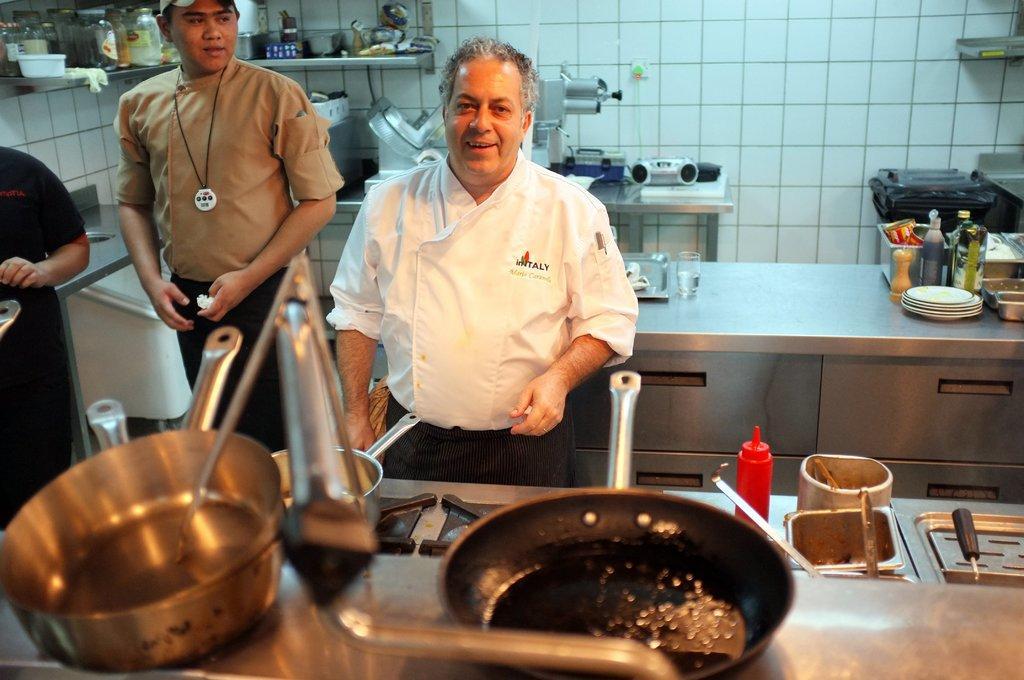Describe this image in one or two sentences. In this picture we can see three people where two men are standing and smiling, pan, bowls, bottles, plates, jars and some objects and in the background we can see the wall. 